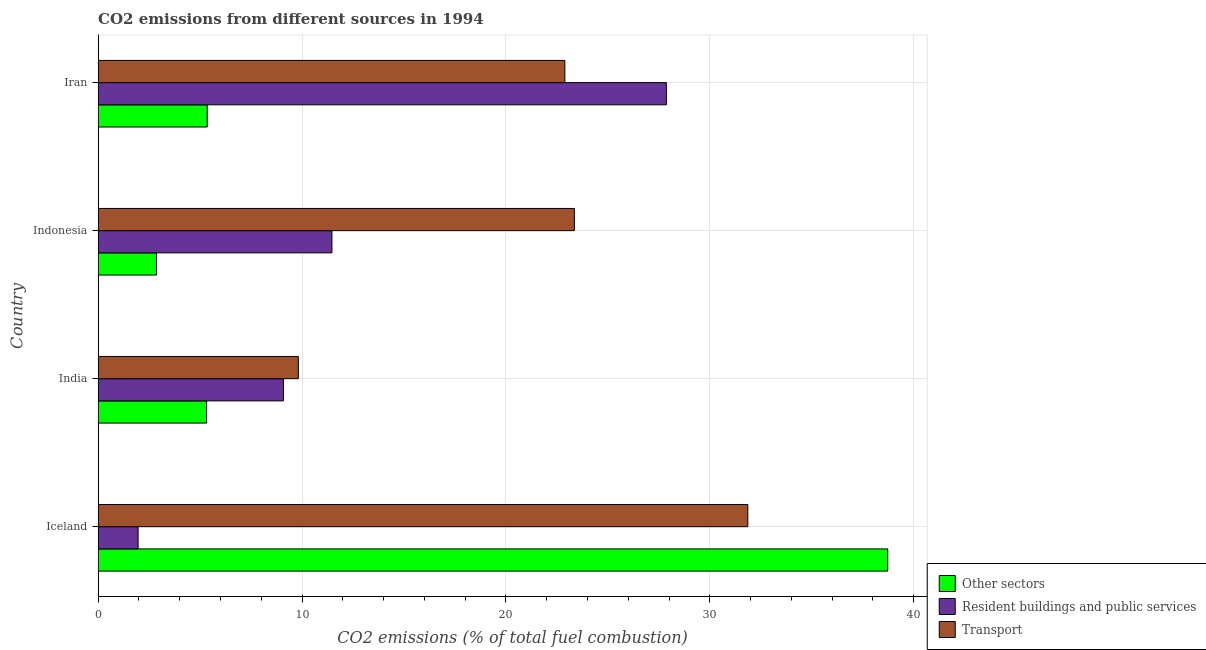How many different coloured bars are there?
Provide a short and direct response. 3. How many groups of bars are there?
Provide a short and direct response. 4. Are the number of bars per tick equal to the number of legend labels?
Your response must be concise. Yes. How many bars are there on the 4th tick from the bottom?
Offer a very short reply. 3. What is the label of the 4th group of bars from the top?
Your answer should be very brief. Iceland. In how many cases, is the number of bars for a given country not equal to the number of legend labels?
Ensure brevity in your answer.  0. What is the percentage of co2 emissions from resident buildings and public services in India?
Ensure brevity in your answer.  9.09. Across all countries, what is the maximum percentage of co2 emissions from transport?
Ensure brevity in your answer.  31.86. Across all countries, what is the minimum percentage of co2 emissions from other sectors?
Ensure brevity in your answer.  2.86. In which country was the percentage of co2 emissions from transport maximum?
Keep it short and to the point. Iceland. In which country was the percentage of co2 emissions from transport minimum?
Make the answer very short. India. What is the total percentage of co2 emissions from resident buildings and public services in the graph?
Ensure brevity in your answer.  50.39. What is the difference between the percentage of co2 emissions from other sectors in Iceland and that in Indonesia?
Your answer should be compact. 35.86. What is the difference between the percentage of co2 emissions from other sectors in Iceland and the percentage of co2 emissions from resident buildings and public services in India?
Your answer should be very brief. 29.64. What is the average percentage of co2 emissions from other sectors per country?
Your answer should be very brief. 13.06. What is the difference between the percentage of co2 emissions from transport and percentage of co2 emissions from other sectors in Iran?
Give a very brief answer. 17.54. In how many countries, is the percentage of co2 emissions from resident buildings and public services greater than 34 %?
Your answer should be compact. 0. What is the ratio of the percentage of co2 emissions from other sectors in Indonesia to that in Iran?
Keep it short and to the point. 0.54. Is the percentage of co2 emissions from other sectors in India less than that in Iran?
Your answer should be compact. Yes. What is the difference between the highest and the second highest percentage of co2 emissions from other sectors?
Give a very brief answer. 33.38. What is the difference between the highest and the lowest percentage of co2 emissions from resident buildings and public services?
Provide a succinct answer. 25.91. In how many countries, is the percentage of co2 emissions from transport greater than the average percentage of co2 emissions from transport taken over all countries?
Give a very brief answer. 3. What does the 2nd bar from the top in Iceland represents?
Ensure brevity in your answer.  Resident buildings and public services. What does the 2nd bar from the bottom in Iceland represents?
Your response must be concise. Resident buildings and public services. How many bars are there?
Give a very brief answer. 12. How many countries are there in the graph?
Keep it short and to the point. 4. Are the values on the major ticks of X-axis written in scientific E-notation?
Make the answer very short. No. Does the graph contain grids?
Keep it short and to the point. Yes. How are the legend labels stacked?
Give a very brief answer. Vertical. What is the title of the graph?
Offer a terse response. CO2 emissions from different sources in 1994. Does "Czech Republic" appear as one of the legend labels in the graph?
Ensure brevity in your answer.  No. What is the label or title of the X-axis?
Your answer should be compact. CO2 emissions (% of total fuel combustion). What is the label or title of the Y-axis?
Give a very brief answer. Country. What is the CO2 emissions (% of total fuel combustion) of Other sectors in Iceland?
Offer a very short reply. 38.73. What is the CO2 emissions (% of total fuel combustion) in Resident buildings and public services in Iceland?
Give a very brief answer. 1.96. What is the CO2 emissions (% of total fuel combustion) in Transport in Iceland?
Provide a short and direct response. 31.86. What is the CO2 emissions (% of total fuel combustion) in Other sectors in India?
Offer a terse response. 5.32. What is the CO2 emissions (% of total fuel combustion) of Resident buildings and public services in India?
Keep it short and to the point. 9.09. What is the CO2 emissions (% of total fuel combustion) in Transport in India?
Ensure brevity in your answer.  9.82. What is the CO2 emissions (% of total fuel combustion) of Other sectors in Indonesia?
Provide a succinct answer. 2.86. What is the CO2 emissions (% of total fuel combustion) in Resident buildings and public services in Indonesia?
Offer a terse response. 11.47. What is the CO2 emissions (% of total fuel combustion) of Transport in Indonesia?
Ensure brevity in your answer.  23.36. What is the CO2 emissions (% of total fuel combustion) in Other sectors in Iran?
Provide a succinct answer. 5.35. What is the CO2 emissions (% of total fuel combustion) in Resident buildings and public services in Iran?
Make the answer very short. 27.87. What is the CO2 emissions (% of total fuel combustion) of Transport in Iran?
Your answer should be compact. 22.89. Across all countries, what is the maximum CO2 emissions (% of total fuel combustion) of Other sectors?
Offer a terse response. 38.73. Across all countries, what is the maximum CO2 emissions (% of total fuel combustion) in Resident buildings and public services?
Provide a succinct answer. 27.87. Across all countries, what is the maximum CO2 emissions (% of total fuel combustion) of Transport?
Ensure brevity in your answer.  31.86. Across all countries, what is the minimum CO2 emissions (% of total fuel combustion) of Other sectors?
Offer a terse response. 2.86. Across all countries, what is the minimum CO2 emissions (% of total fuel combustion) of Resident buildings and public services?
Ensure brevity in your answer.  1.96. Across all countries, what is the minimum CO2 emissions (% of total fuel combustion) in Transport?
Your answer should be compact. 9.82. What is the total CO2 emissions (% of total fuel combustion) of Other sectors in the graph?
Offer a very short reply. 52.26. What is the total CO2 emissions (% of total fuel combustion) in Resident buildings and public services in the graph?
Your response must be concise. 50.39. What is the total CO2 emissions (% of total fuel combustion) of Transport in the graph?
Your response must be concise. 87.93. What is the difference between the CO2 emissions (% of total fuel combustion) in Other sectors in Iceland and that in India?
Give a very brief answer. 33.41. What is the difference between the CO2 emissions (% of total fuel combustion) in Resident buildings and public services in Iceland and that in India?
Your answer should be very brief. -7.13. What is the difference between the CO2 emissions (% of total fuel combustion) of Transport in Iceland and that in India?
Offer a very short reply. 22.04. What is the difference between the CO2 emissions (% of total fuel combustion) of Other sectors in Iceland and that in Indonesia?
Keep it short and to the point. 35.86. What is the difference between the CO2 emissions (% of total fuel combustion) in Resident buildings and public services in Iceland and that in Indonesia?
Make the answer very short. -9.51. What is the difference between the CO2 emissions (% of total fuel combustion) of Transport in Iceland and that in Indonesia?
Your answer should be compact. 8.51. What is the difference between the CO2 emissions (% of total fuel combustion) in Other sectors in Iceland and that in Iran?
Provide a succinct answer. 33.37. What is the difference between the CO2 emissions (% of total fuel combustion) in Resident buildings and public services in Iceland and that in Iran?
Ensure brevity in your answer.  -25.91. What is the difference between the CO2 emissions (% of total fuel combustion) in Transport in Iceland and that in Iran?
Provide a succinct answer. 8.97. What is the difference between the CO2 emissions (% of total fuel combustion) of Other sectors in India and that in Indonesia?
Give a very brief answer. 2.46. What is the difference between the CO2 emissions (% of total fuel combustion) in Resident buildings and public services in India and that in Indonesia?
Give a very brief answer. -2.38. What is the difference between the CO2 emissions (% of total fuel combustion) of Transport in India and that in Indonesia?
Ensure brevity in your answer.  -13.54. What is the difference between the CO2 emissions (% of total fuel combustion) of Other sectors in India and that in Iran?
Your response must be concise. -0.03. What is the difference between the CO2 emissions (% of total fuel combustion) of Resident buildings and public services in India and that in Iran?
Offer a very short reply. -18.78. What is the difference between the CO2 emissions (% of total fuel combustion) of Transport in India and that in Iran?
Make the answer very short. -13.07. What is the difference between the CO2 emissions (% of total fuel combustion) of Other sectors in Indonesia and that in Iran?
Your answer should be compact. -2.49. What is the difference between the CO2 emissions (% of total fuel combustion) in Resident buildings and public services in Indonesia and that in Iran?
Your answer should be very brief. -16.4. What is the difference between the CO2 emissions (% of total fuel combustion) in Transport in Indonesia and that in Iran?
Provide a succinct answer. 0.47. What is the difference between the CO2 emissions (% of total fuel combustion) in Other sectors in Iceland and the CO2 emissions (% of total fuel combustion) in Resident buildings and public services in India?
Provide a short and direct response. 29.64. What is the difference between the CO2 emissions (% of total fuel combustion) in Other sectors in Iceland and the CO2 emissions (% of total fuel combustion) in Transport in India?
Offer a terse response. 28.91. What is the difference between the CO2 emissions (% of total fuel combustion) in Resident buildings and public services in Iceland and the CO2 emissions (% of total fuel combustion) in Transport in India?
Your answer should be very brief. -7.86. What is the difference between the CO2 emissions (% of total fuel combustion) in Other sectors in Iceland and the CO2 emissions (% of total fuel combustion) in Resident buildings and public services in Indonesia?
Provide a succinct answer. 27.26. What is the difference between the CO2 emissions (% of total fuel combustion) in Other sectors in Iceland and the CO2 emissions (% of total fuel combustion) in Transport in Indonesia?
Provide a succinct answer. 15.37. What is the difference between the CO2 emissions (% of total fuel combustion) in Resident buildings and public services in Iceland and the CO2 emissions (% of total fuel combustion) in Transport in Indonesia?
Provide a succinct answer. -21.4. What is the difference between the CO2 emissions (% of total fuel combustion) in Other sectors in Iceland and the CO2 emissions (% of total fuel combustion) in Resident buildings and public services in Iran?
Ensure brevity in your answer.  10.86. What is the difference between the CO2 emissions (% of total fuel combustion) in Other sectors in Iceland and the CO2 emissions (% of total fuel combustion) in Transport in Iran?
Your answer should be compact. 15.84. What is the difference between the CO2 emissions (% of total fuel combustion) in Resident buildings and public services in Iceland and the CO2 emissions (% of total fuel combustion) in Transport in Iran?
Keep it short and to the point. -20.93. What is the difference between the CO2 emissions (% of total fuel combustion) of Other sectors in India and the CO2 emissions (% of total fuel combustion) of Resident buildings and public services in Indonesia?
Your answer should be very brief. -6.15. What is the difference between the CO2 emissions (% of total fuel combustion) of Other sectors in India and the CO2 emissions (% of total fuel combustion) of Transport in Indonesia?
Make the answer very short. -18.04. What is the difference between the CO2 emissions (% of total fuel combustion) of Resident buildings and public services in India and the CO2 emissions (% of total fuel combustion) of Transport in Indonesia?
Offer a very short reply. -14.27. What is the difference between the CO2 emissions (% of total fuel combustion) of Other sectors in India and the CO2 emissions (% of total fuel combustion) of Resident buildings and public services in Iran?
Offer a very short reply. -22.55. What is the difference between the CO2 emissions (% of total fuel combustion) in Other sectors in India and the CO2 emissions (% of total fuel combustion) in Transport in Iran?
Your response must be concise. -17.57. What is the difference between the CO2 emissions (% of total fuel combustion) of Resident buildings and public services in India and the CO2 emissions (% of total fuel combustion) of Transport in Iran?
Make the answer very short. -13.8. What is the difference between the CO2 emissions (% of total fuel combustion) of Other sectors in Indonesia and the CO2 emissions (% of total fuel combustion) of Resident buildings and public services in Iran?
Your response must be concise. -25.01. What is the difference between the CO2 emissions (% of total fuel combustion) of Other sectors in Indonesia and the CO2 emissions (% of total fuel combustion) of Transport in Iran?
Make the answer very short. -20.03. What is the difference between the CO2 emissions (% of total fuel combustion) of Resident buildings and public services in Indonesia and the CO2 emissions (% of total fuel combustion) of Transport in Iran?
Your response must be concise. -11.42. What is the average CO2 emissions (% of total fuel combustion) in Other sectors per country?
Keep it short and to the point. 13.06. What is the average CO2 emissions (% of total fuel combustion) in Resident buildings and public services per country?
Offer a terse response. 12.6. What is the average CO2 emissions (% of total fuel combustion) in Transport per country?
Provide a short and direct response. 21.98. What is the difference between the CO2 emissions (% of total fuel combustion) in Other sectors and CO2 emissions (% of total fuel combustion) in Resident buildings and public services in Iceland?
Provide a short and direct response. 36.76. What is the difference between the CO2 emissions (% of total fuel combustion) of Other sectors and CO2 emissions (% of total fuel combustion) of Transport in Iceland?
Your response must be concise. 6.86. What is the difference between the CO2 emissions (% of total fuel combustion) in Resident buildings and public services and CO2 emissions (% of total fuel combustion) in Transport in Iceland?
Give a very brief answer. -29.9. What is the difference between the CO2 emissions (% of total fuel combustion) of Other sectors and CO2 emissions (% of total fuel combustion) of Resident buildings and public services in India?
Make the answer very short. -3.77. What is the difference between the CO2 emissions (% of total fuel combustion) in Other sectors and CO2 emissions (% of total fuel combustion) in Transport in India?
Offer a very short reply. -4.5. What is the difference between the CO2 emissions (% of total fuel combustion) of Resident buildings and public services and CO2 emissions (% of total fuel combustion) of Transport in India?
Offer a very short reply. -0.73. What is the difference between the CO2 emissions (% of total fuel combustion) of Other sectors and CO2 emissions (% of total fuel combustion) of Resident buildings and public services in Indonesia?
Keep it short and to the point. -8.61. What is the difference between the CO2 emissions (% of total fuel combustion) of Other sectors and CO2 emissions (% of total fuel combustion) of Transport in Indonesia?
Keep it short and to the point. -20.49. What is the difference between the CO2 emissions (% of total fuel combustion) of Resident buildings and public services and CO2 emissions (% of total fuel combustion) of Transport in Indonesia?
Offer a very short reply. -11.89. What is the difference between the CO2 emissions (% of total fuel combustion) in Other sectors and CO2 emissions (% of total fuel combustion) in Resident buildings and public services in Iran?
Your answer should be compact. -22.52. What is the difference between the CO2 emissions (% of total fuel combustion) in Other sectors and CO2 emissions (% of total fuel combustion) in Transport in Iran?
Your answer should be compact. -17.54. What is the difference between the CO2 emissions (% of total fuel combustion) in Resident buildings and public services and CO2 emissions (% of total fuel combustion) in Transport in Iran?
Keep it short and to the point. 4.98. What is the ratio of the CO2 emissions (% of total fuel combustion) of Other sectors in Iceland to that in India?
Your answer should be very brief. 7.28. What is the ratio of the CO2 emissions (% of total fuel combustion) in Resident buildings and public services in Iceland to that in India?
Keep it short and to the point. 0.22. What is the ratio of the CO2 emissions (% of total fuel combustion) of Transport in Iceland to that in India?
Keep it short and to the point. 3.24. What is the ratio of the CO2 emissions (% of total fuel combustion) of Other sectors in Iceland to that in Indonesia?
Keep it short and to the point. 13.53. What is the ratio of the CO2 emissions (% of total fuel combustion) in Resident buildings and public services in Iceland to that in Indonesia?
Ensure brevity in your answer.  0.17. What is the ratio of the CO2 emissions (% of total fuel combustion) in Transport in Iceland to that in Indonesia?
Offer a terse response. 1.36. What is the ratio of the CO2 emissions (% of total fuel combustion) of Other sectors in Iceland to that in Iran?
Make the answer very short. 7.24. What is the ratio of the CO2 emissions (% of total fuel combustion) of Resident buildings and public services in Iceland to that in Iran?
Your answer should be very brief. 0.07. What is the ratio of the CO2 emissions (% of total fuel combustion) of Transport in Iceland to that in Iran?
Your answer should be very brief. 1.39. What is the ratio of the CO2 emissions (% of total fuel combustion) of Other sectors in India to that in Indonesia?
Your response must be concise. 1.86. What is the ratio of the CO2 emissions (% of total fuel combustion) in Resident buildings and public services in India to that in Indonesia?
Your answer should be compact. 0.79. What is the ratio of the CO2 emissions (% of total fuel combustion) in Transport in India to that in Indonesia?
Provide a succinct answer. 0.42. What is the ratio of the CO2 emissions (% of total fuel combustion) in Other sectors in India to that in Iran?
Your response must be concise. 0.99. What is the ratio of the CO2 emissions (% of total fuel combustion) in Resident buildings and public services in India to that in Iran?
Your answer should be very brief. 0.33. What is the ratio of the CO2 emissions (% of total fuel combustion) in Transport in India to that in Iran?
Ensure brevity in your answer.  0.43. What is the ratio of the CO2 emissions (% of total fuel combustion) in Other sectors in Indonesia to that in Iran?
Your answer should be compact. 0.53. What is the ratio of the CO2 emissions (% of total fuel combustion) in Resident buildings and public services in Indonesia to that in Iran?
Your answer should be very brief. 0.41. What is the ratio of the CO2 emissions (% of total fuel combustion) in Transport in Indonesia to that in Iran?
Make the answer very short. 1.02. What is the difference between the highest and the second highest CO2 emissions (% of total fuel combustion) in Other sectors?
Your answer should be compact. 33.37. What is the difference between the highest and the second highest CO2 emissions (% of total fuel combustion) in Resident buildings and public services?
Keep it short and to the point. 16.4. What is the difference between the highest and the second highest CO2 emissions (% of total fuel combustion) of Transport?
Offer a very short reply. 8.51. What is the difference between the highest and the lowest CO2 emissions (% of total fuel combustion) of Other sectors?
Provide a succinct answer. 35.86. What is the difference between the highest and the lowest CO2 emissions (% of total fuel combustion) in Resident buildings and public services?
Your answer should be compact. 25.91. What is the difference between the highest and the lowest CO2 emissions (% of total fuel combustion) in Transport?
Your answer should be compact. 22.04. 